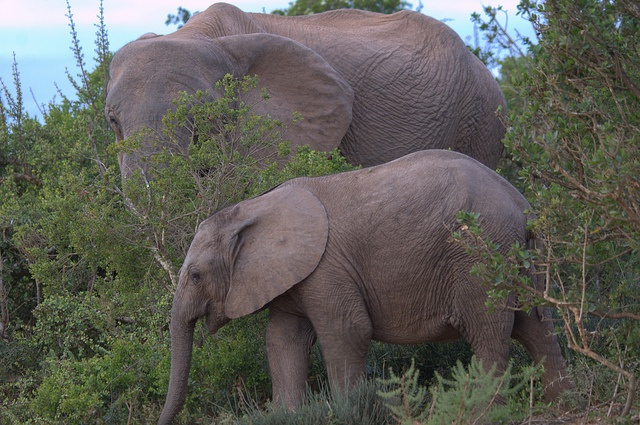Describe the objects in this image and their specific colors. I can see elephant in lavender, gray, and black tones, elephant in lavender and gray tones, and elephant in lavender, gray, darkgreen, olive, and black tones in this image. 